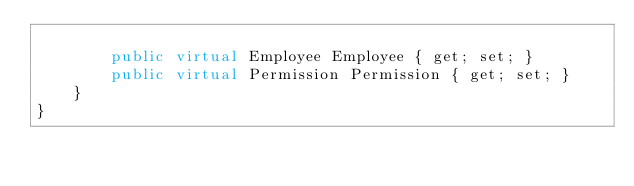Convert code to text. <code><loc_0><loc_0><loc_500><loc_500><_C#_>    
        public virtual Employee Employee { get; set; }
        public virtual Permission Permission { get; set; }
    }
}
</code> 